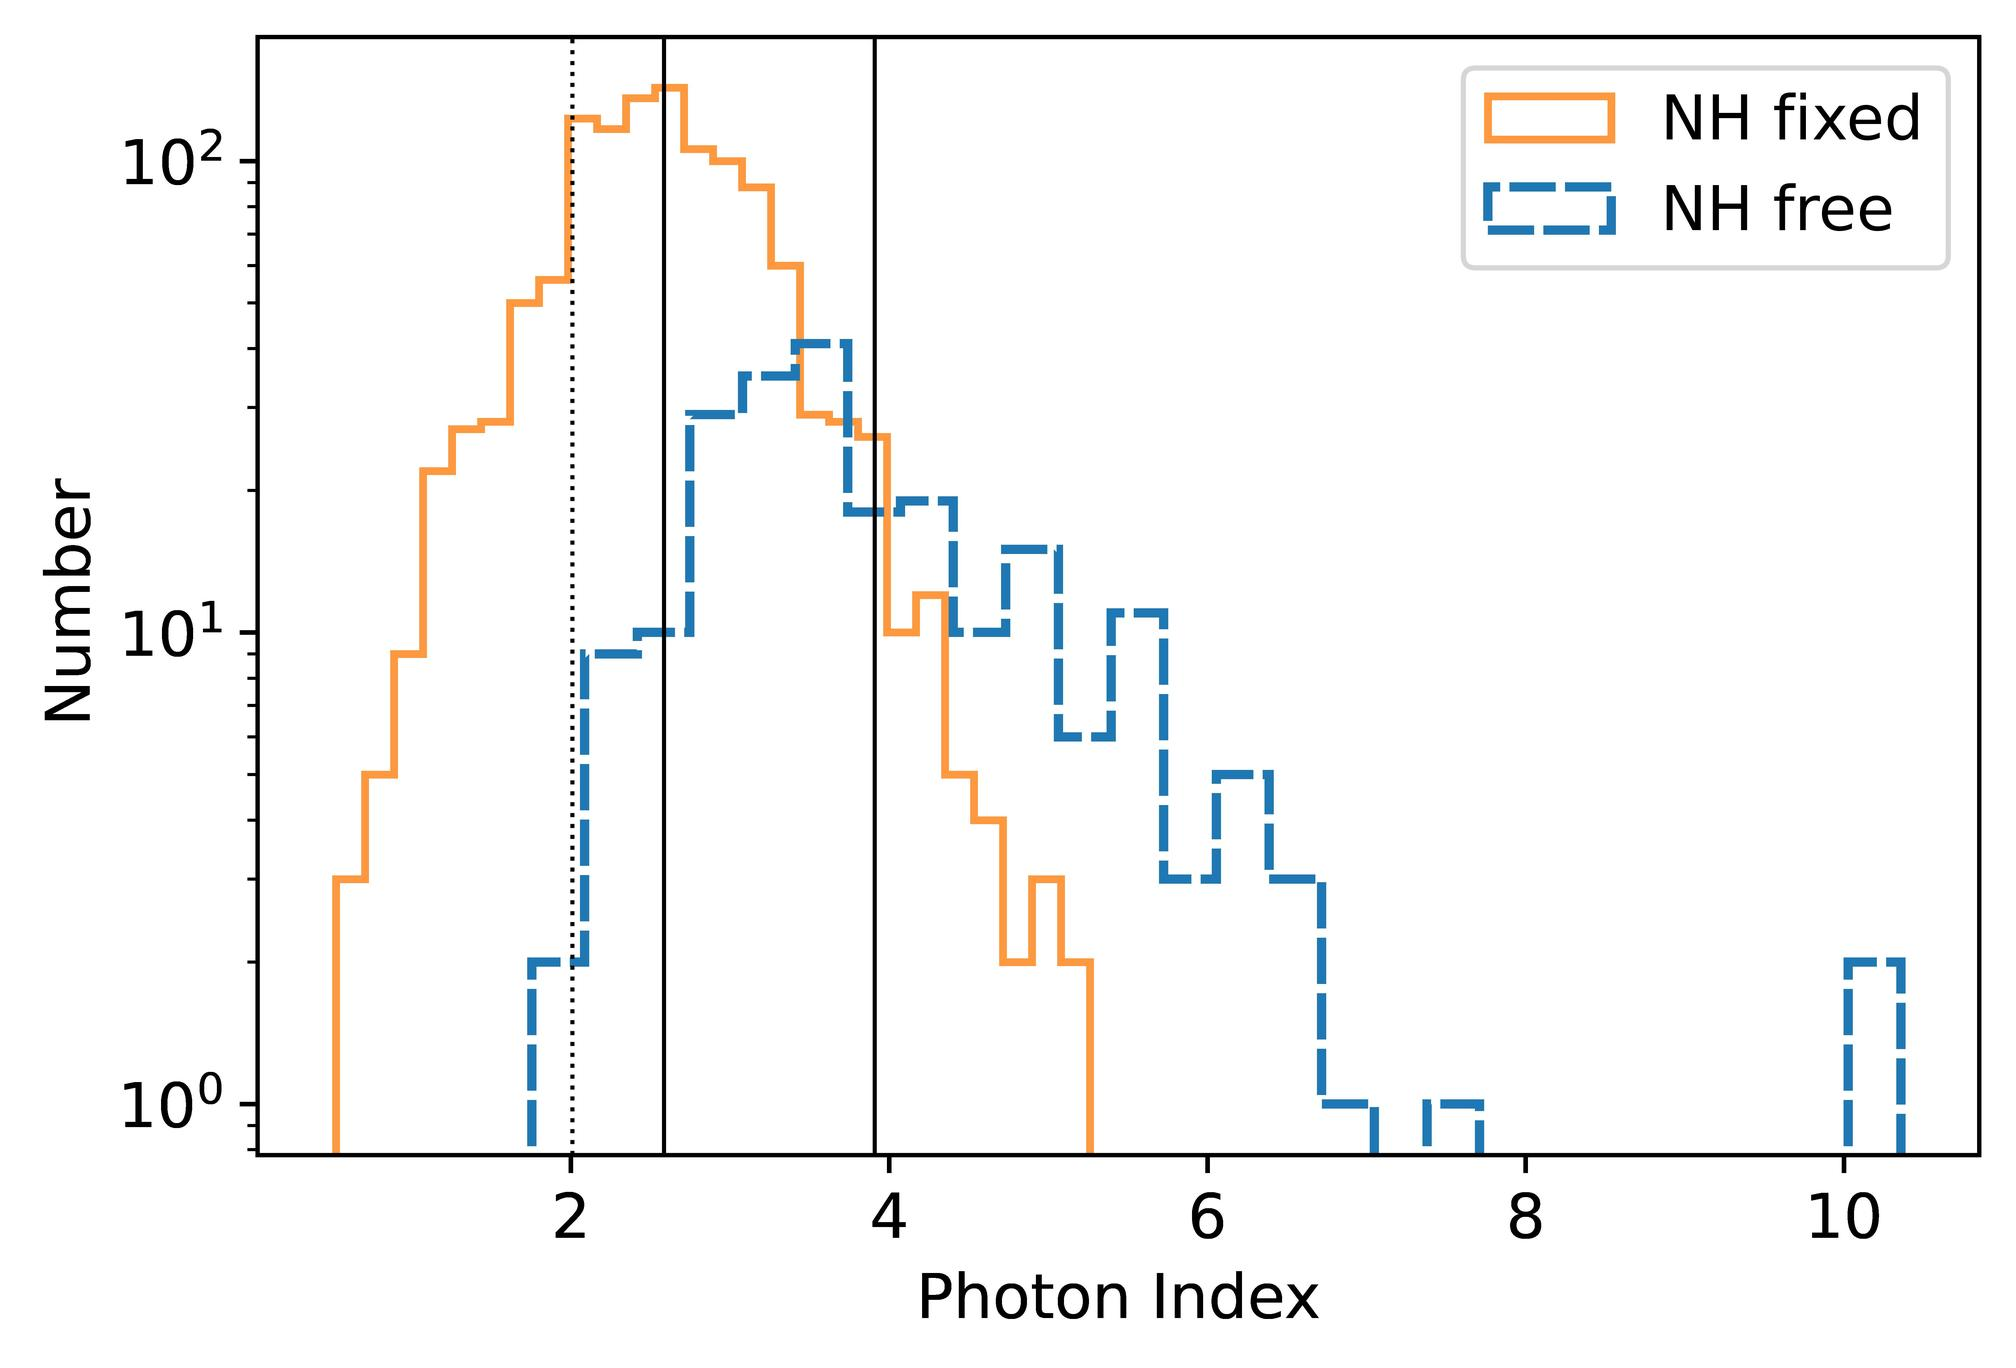What can we infer about the photon index based on this histogram? Based on the histogram, one can infer that the photon index mainly clusters around values of 2.0 to 6.0 for both NH fixed and NH free, indicating a common range of photon emission processes or energies typically observed in this study. Peaks around specific indices, such as around 3.0 for NH fixed and between 4.0 and 5.0 for NH free, hint at more probable or dominant conditions under different modeling assumptions. This variation is crucial for astrophysicists when they interpret astronomical data, as it helps identify typical or anomalous conditions. 